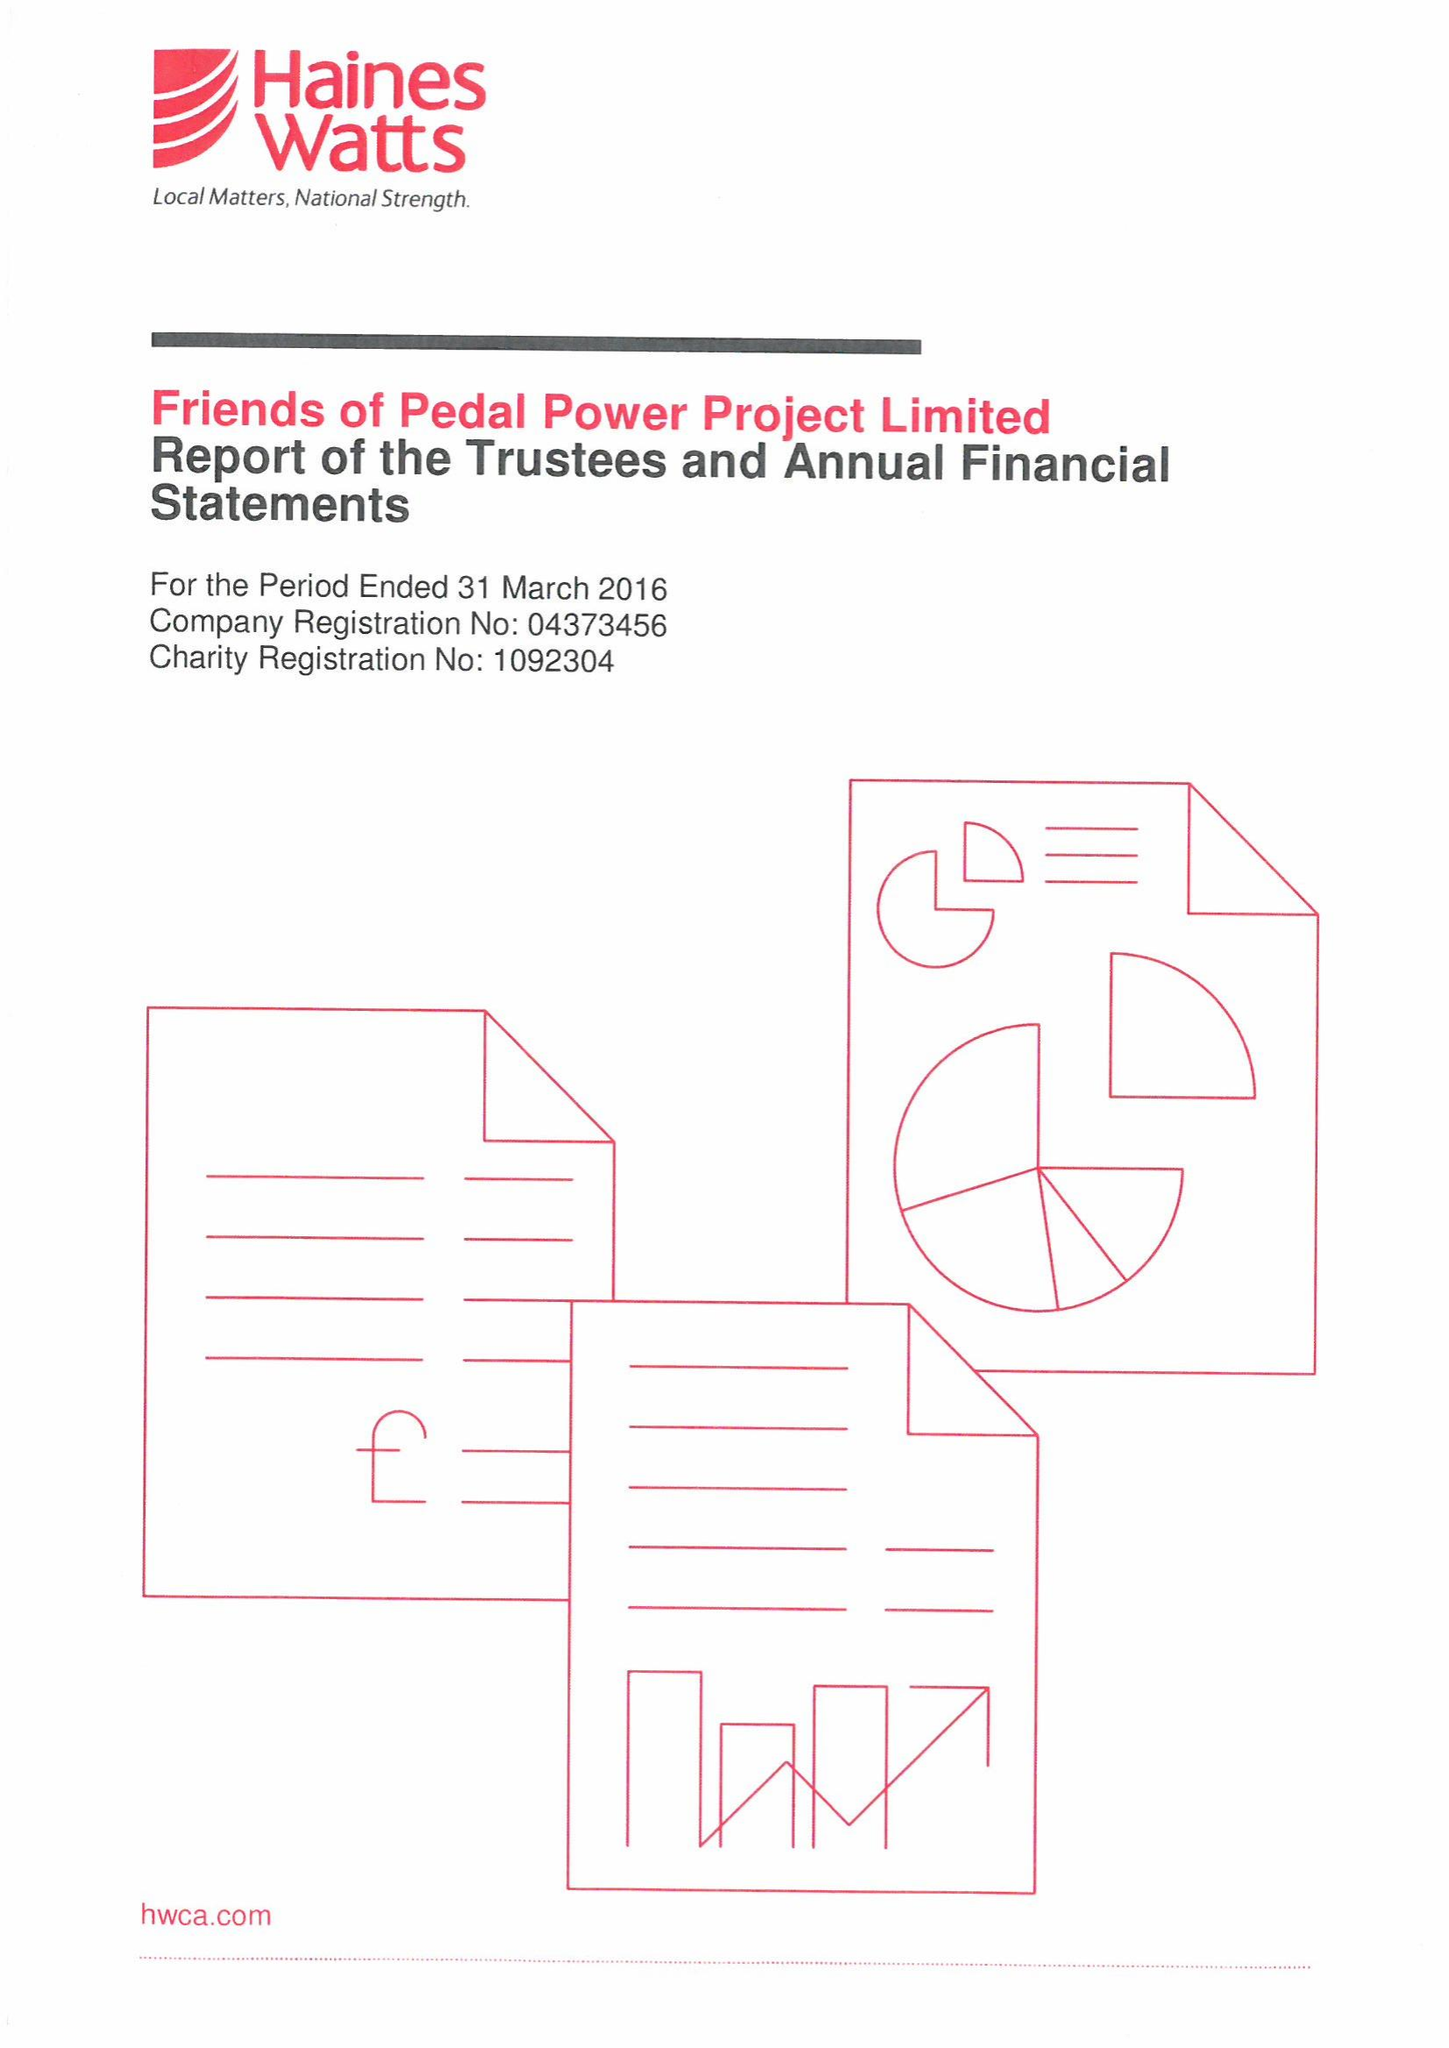What is the value for the address__post_town?
Answer the question using a single word or phrase. CARDIFF 